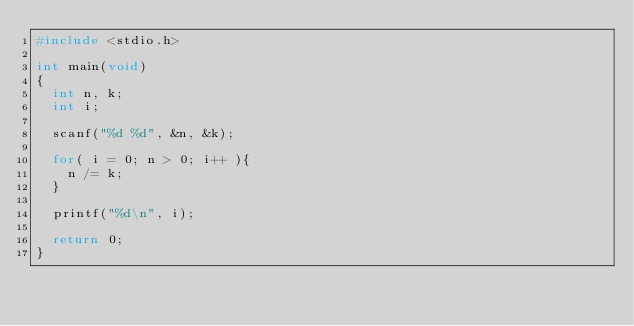Convert code to text. <code><loc_0><loc_0><loc_500><loc_500><_C_>#include <stdio.h>

int main(void)
{
  int n, k;
  int i;
  
  scanf("%d %d", &n, &k);
  
  for( i = 0; n > 0; i++ ){
    n /= k;
  }
  
  printf("%d\n", i);
  
  return 0;
}</code> 